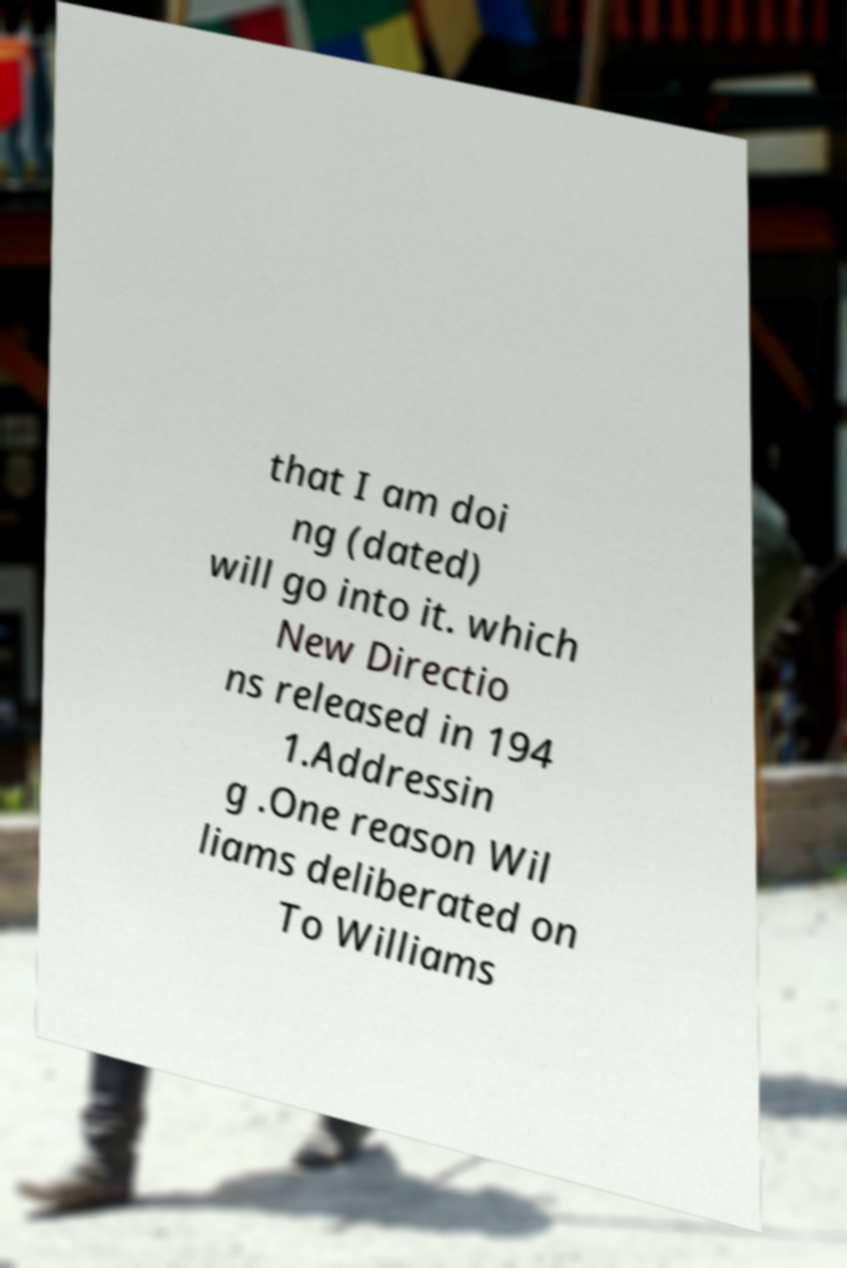There's text embedded in this image that I need extracted. Can you transcribe it verbatim? that I am doi ng (dated) will go into it. which New Directio ns released in 194 1.Addressin g .One reason Wil liams deliberated on To Williams 